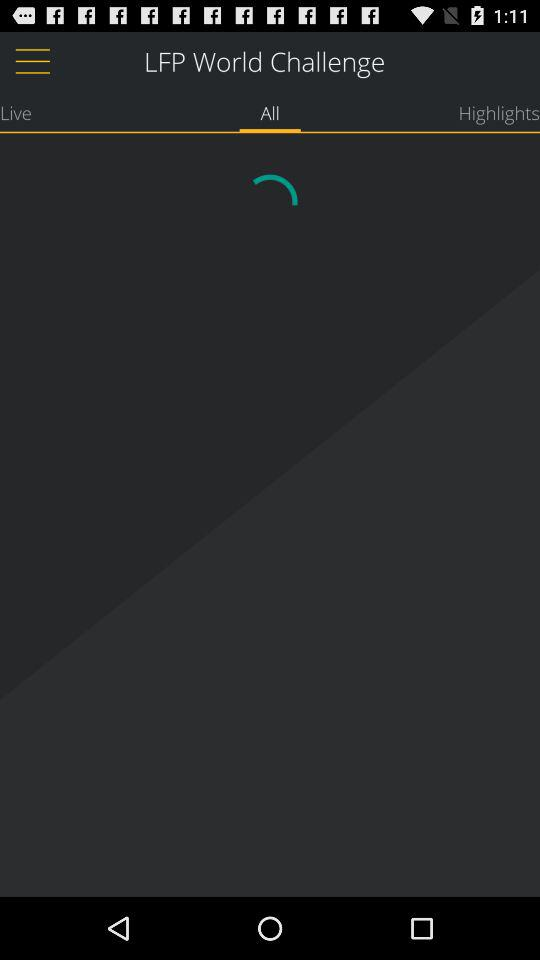Which tab am I on? You are on the tab "All". 